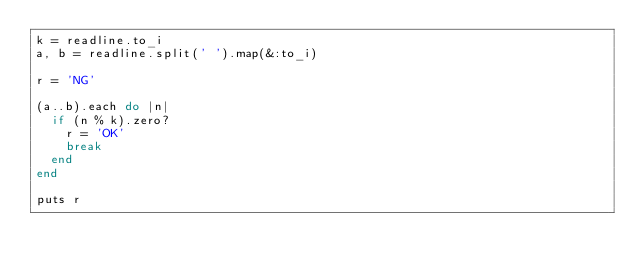Convert code to text. <code><loc_0><loc_0><loc_500><loc_500><_Ruby_>k = readline.to_i
a, b = readline.split(' ').map(&:to_i)

r = 'NG'

(a..b).each do |n|
  if (n % k).zero?
    r = 'OK'
    break
  end
end

puts r
</code> 